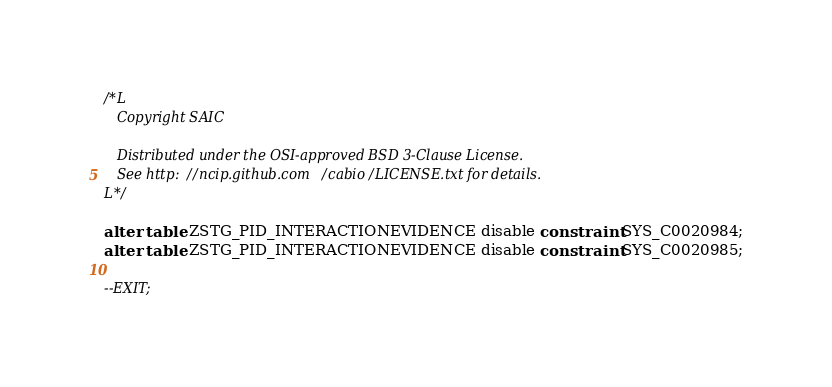<code> <loc_0><loc_0><loc_500><loc_500><_SQL_>/*L
   Copyright SAIC

   Distributed under the OSI-approved BSD 3-Clause License.
   See http://ncip.github.com/cabio/LICENSE.txt for details.
L*/

alter table ZSTG_PID_INTERACTIONEVIDENCE disable constraint SYS_C0020984;
alter table ZSTG_PID_INTERACTIONEVIDENCE disable constraint SYS_C0020985;

--EXIT;
</code> 